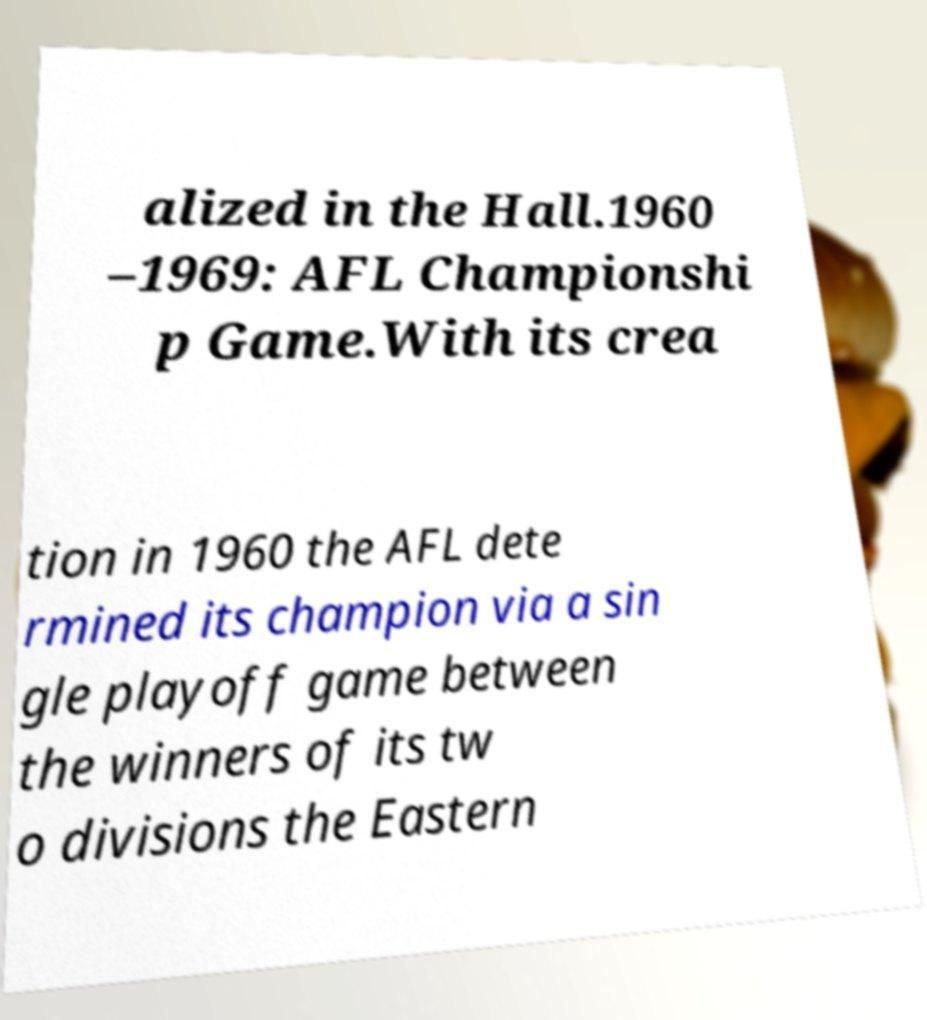Can you accurately transcribe the text from the provided image for me? alized in the Hall.1960 –1969: AFL Championshi p Game.With its crea tion in 1960 the AFL dete rmined its champion via a sin gle playoff game between the winners of its tw o divisions the Eastern 